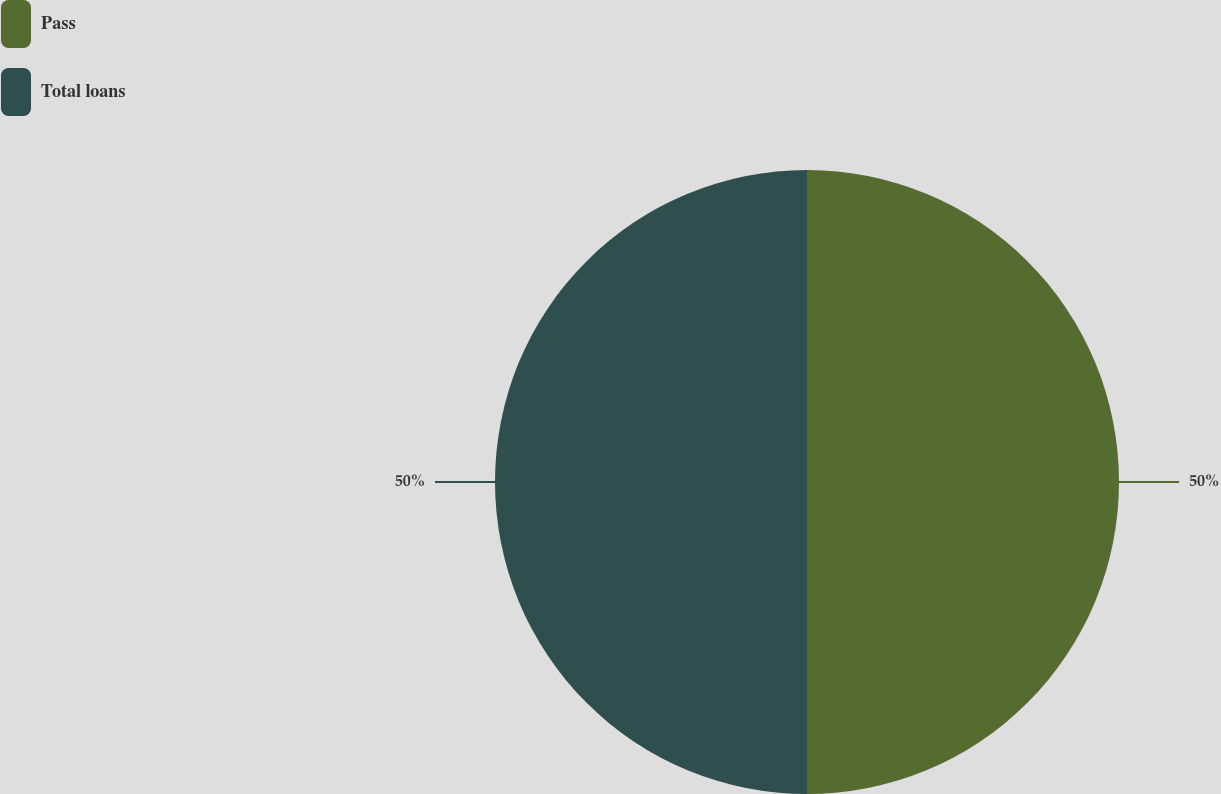Convert chart. <chart><loc_0><loc_0><loc_500><loc_500><pie_chart><fcel>Pass<fcel>Total loans<nl><fcel>50.0%<fcel>50.0%<nl></chart> 